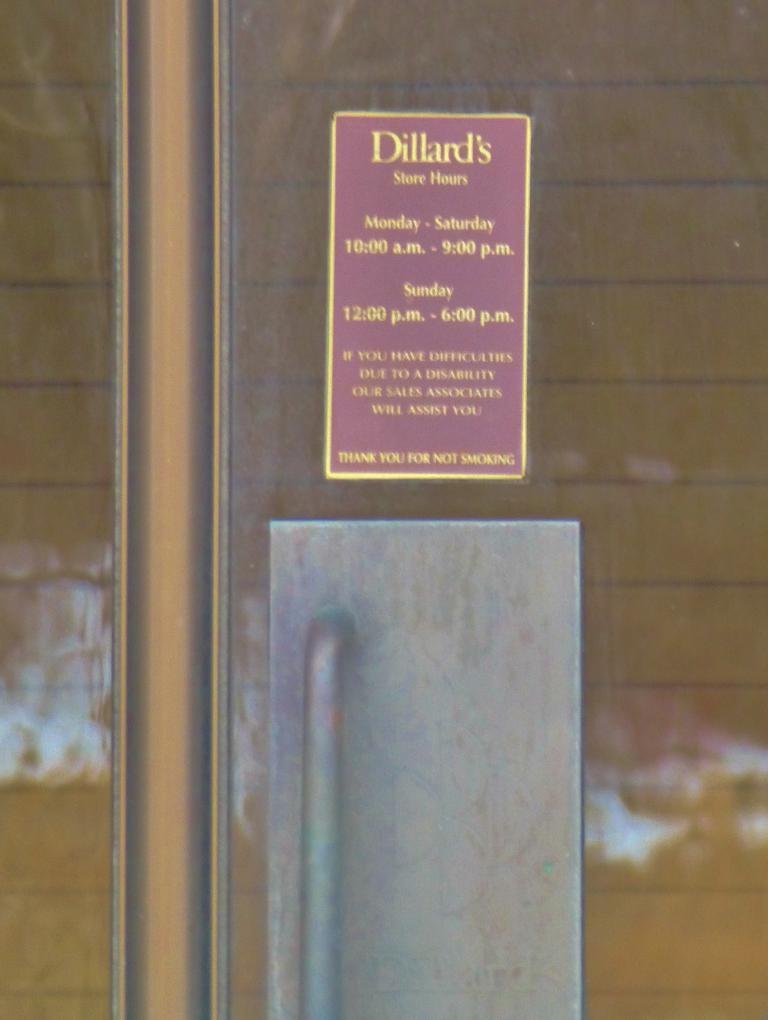How would you summarize this image in a sentence or two? In this image we can see a door, there is a handle on it, and a poster with some text on it, also we can see the wall. 